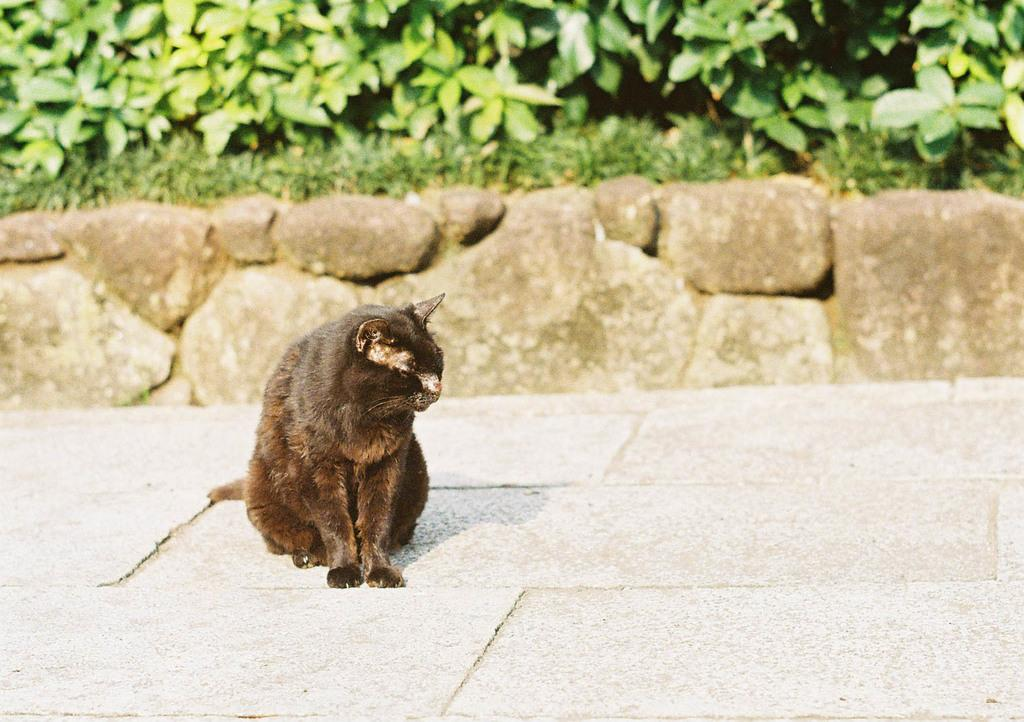What type of animal is in the image? There is a cat in the image. What can be seen in the background of the image? There are plants and stones in the background of the image. What type of bird is guiding the cat through the scene in the image? There are no birds present in the image, and the cat is not being guided through a scene. 